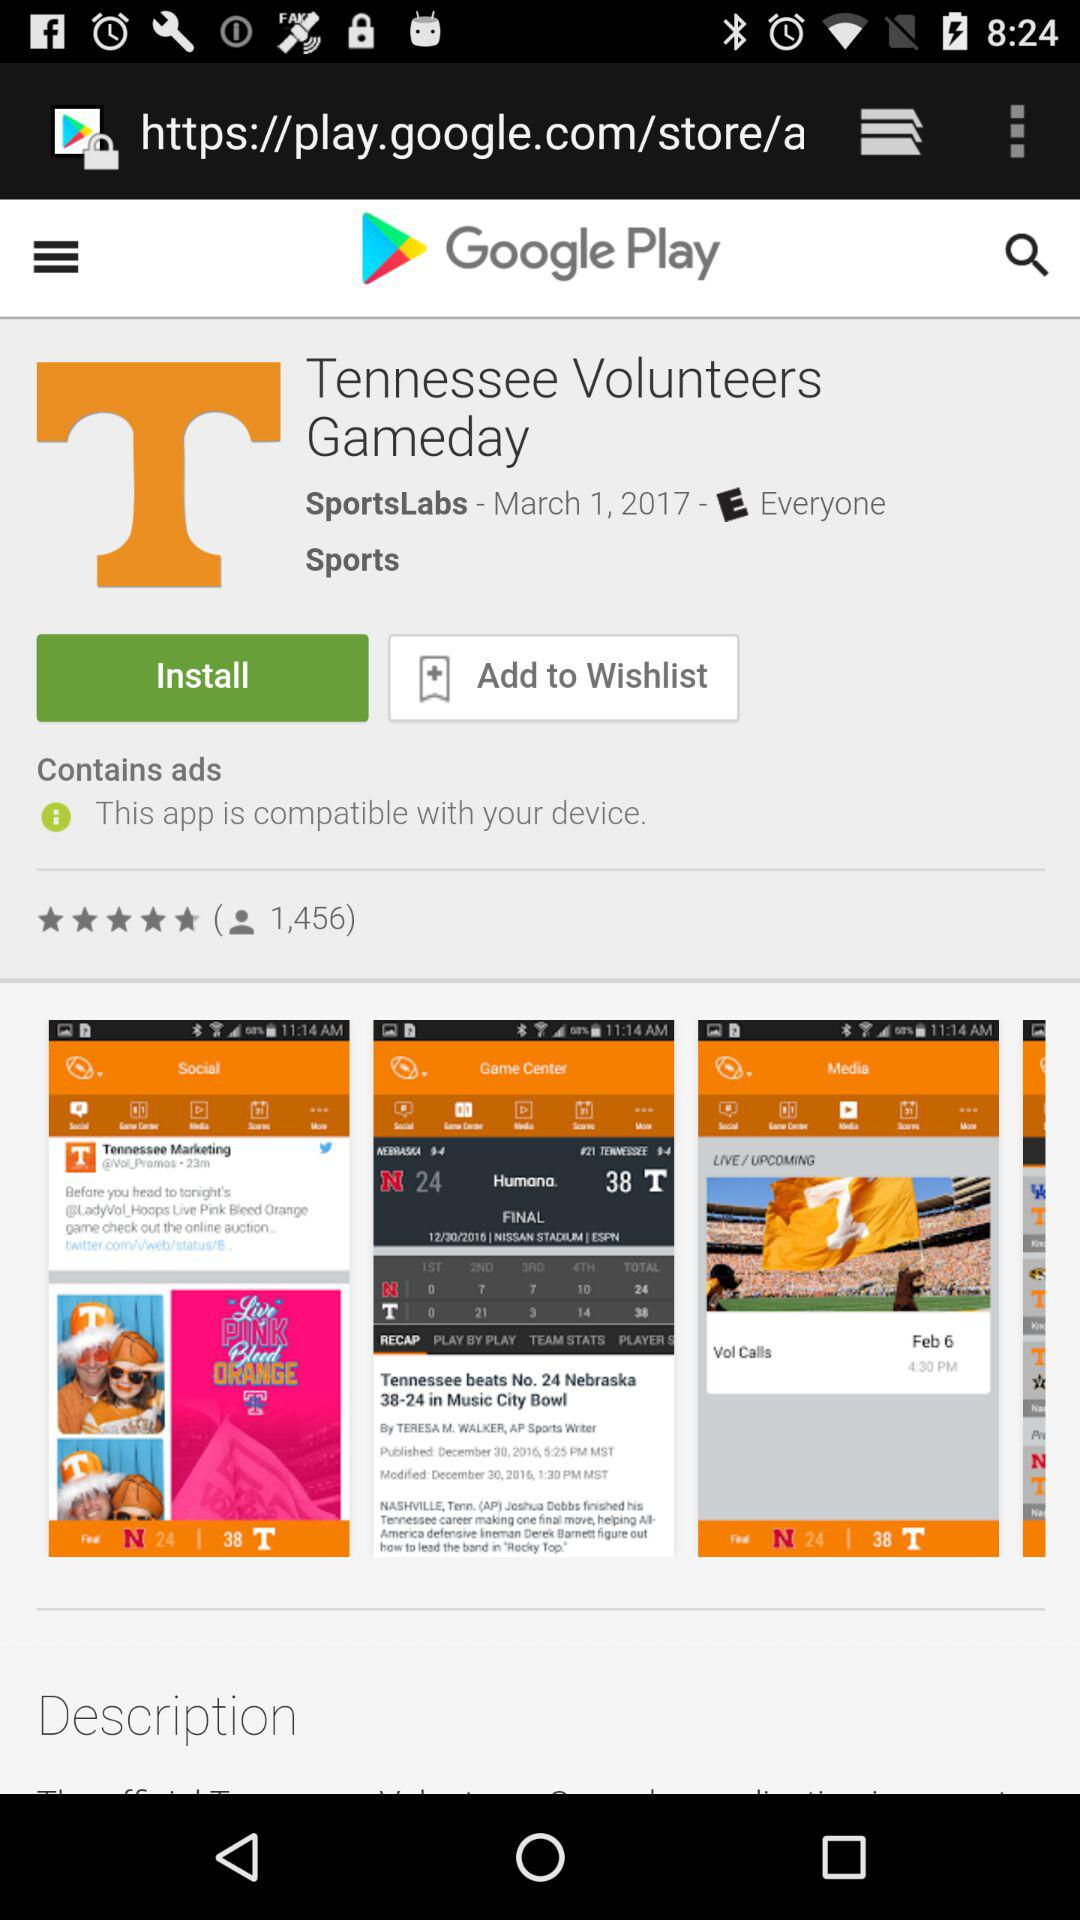What is the name of the application? The application name is "Tennessee Volunteers Gameday". 